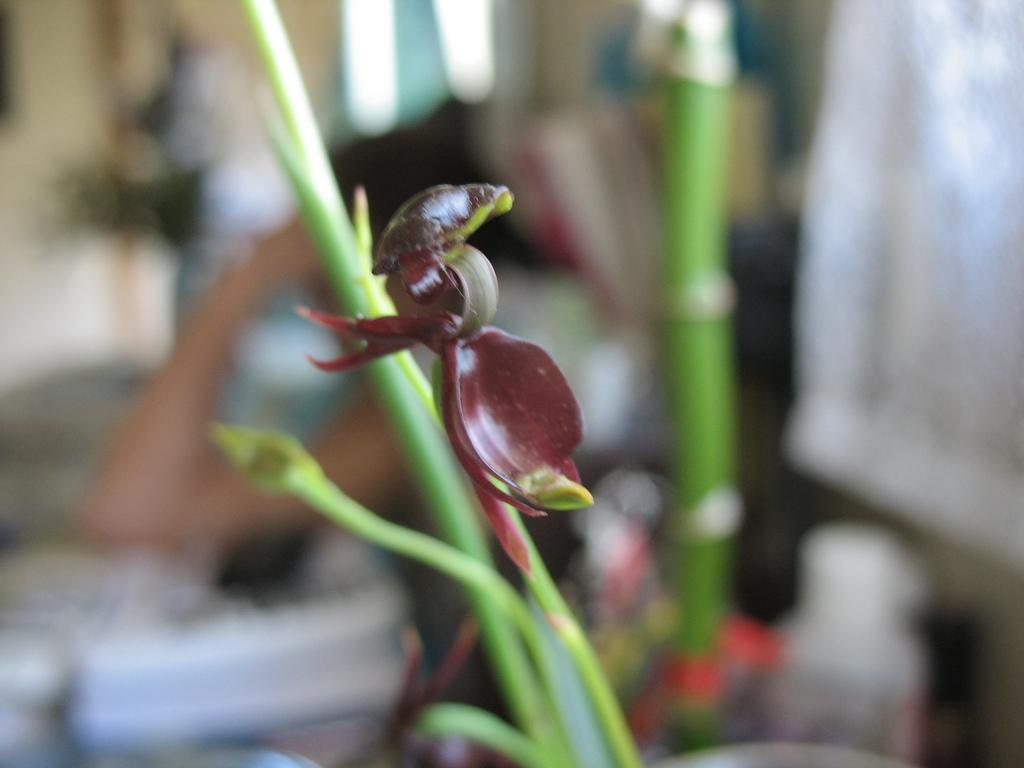What type of creature can be seen in the image? There is an insect in the image. Where is the insect located in the image? The insect is on a stem. What type of lead is the secretary holding in the image? There is no lead or secretary present in the image; it only features an insect on a stem. 